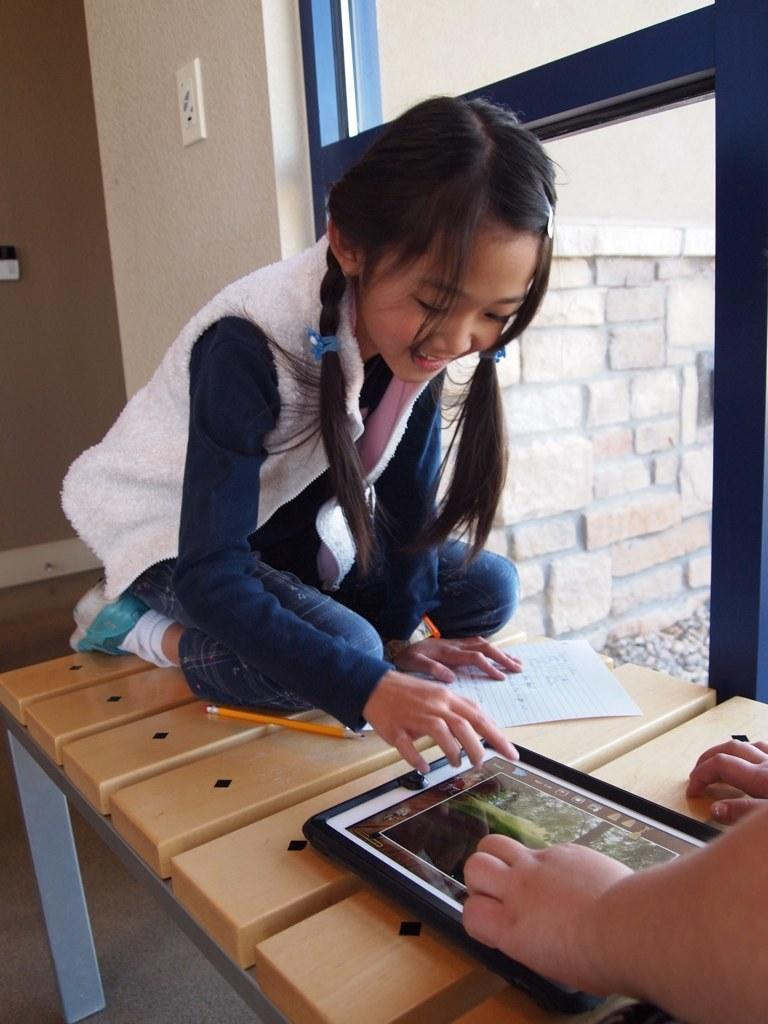What is the person in the image doing? The person is sitting on a table. What is in front of the person on the table? There is a gadget in front of the person. What else is on the table besides the gadget? There is a paper and a pencil on the table. What can be seen at the right side of the table? There is a window at the right side of the table. What nerve is being stimulated by the gadget in the image? There is no mention of a nerve or any medical context in the image, so it is not possible to answer that question. 